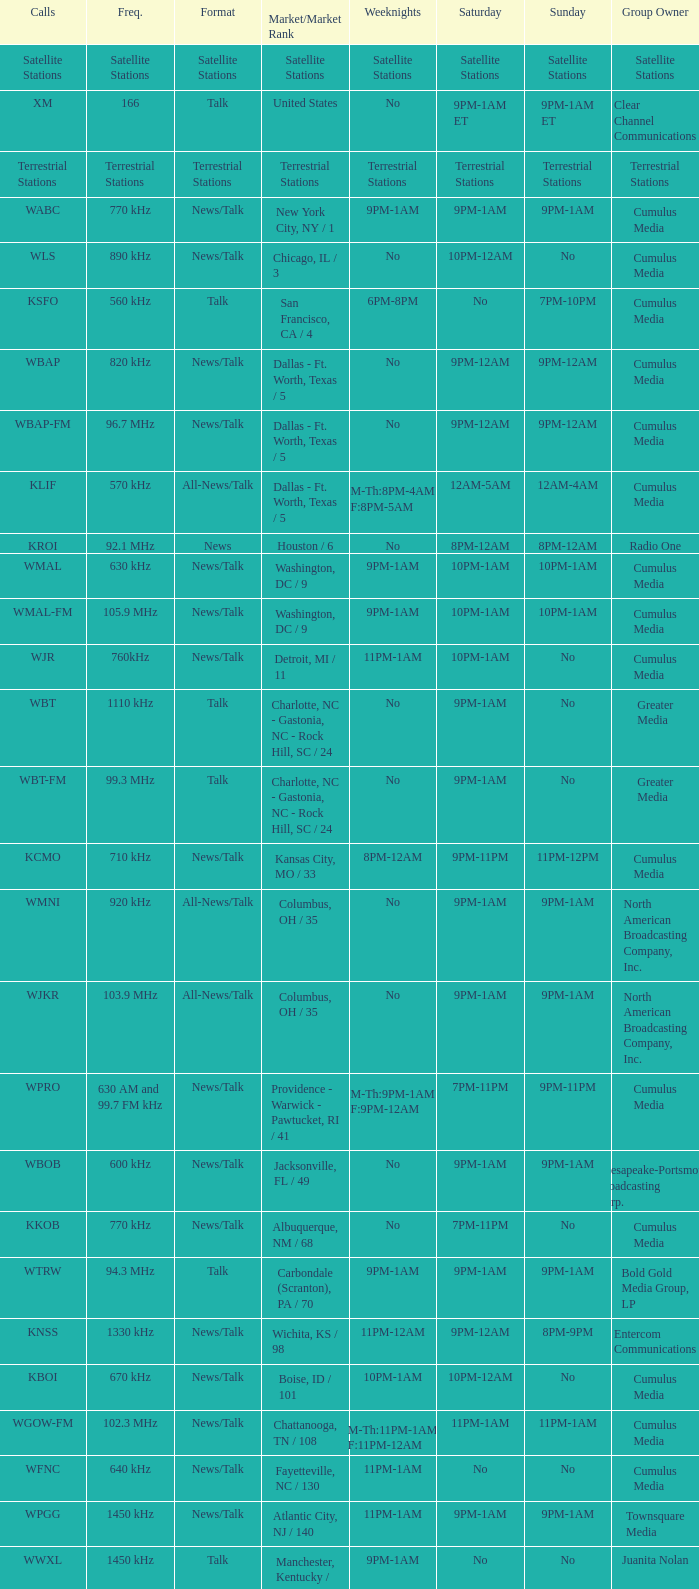What is the target market for the 11pm-1am saturday game? Chattanooga, TN / 108. 